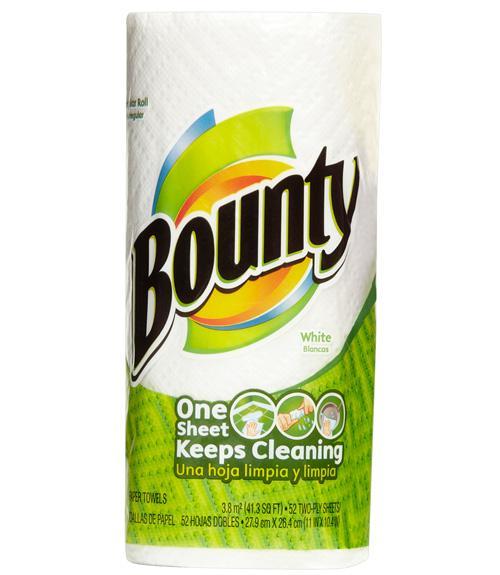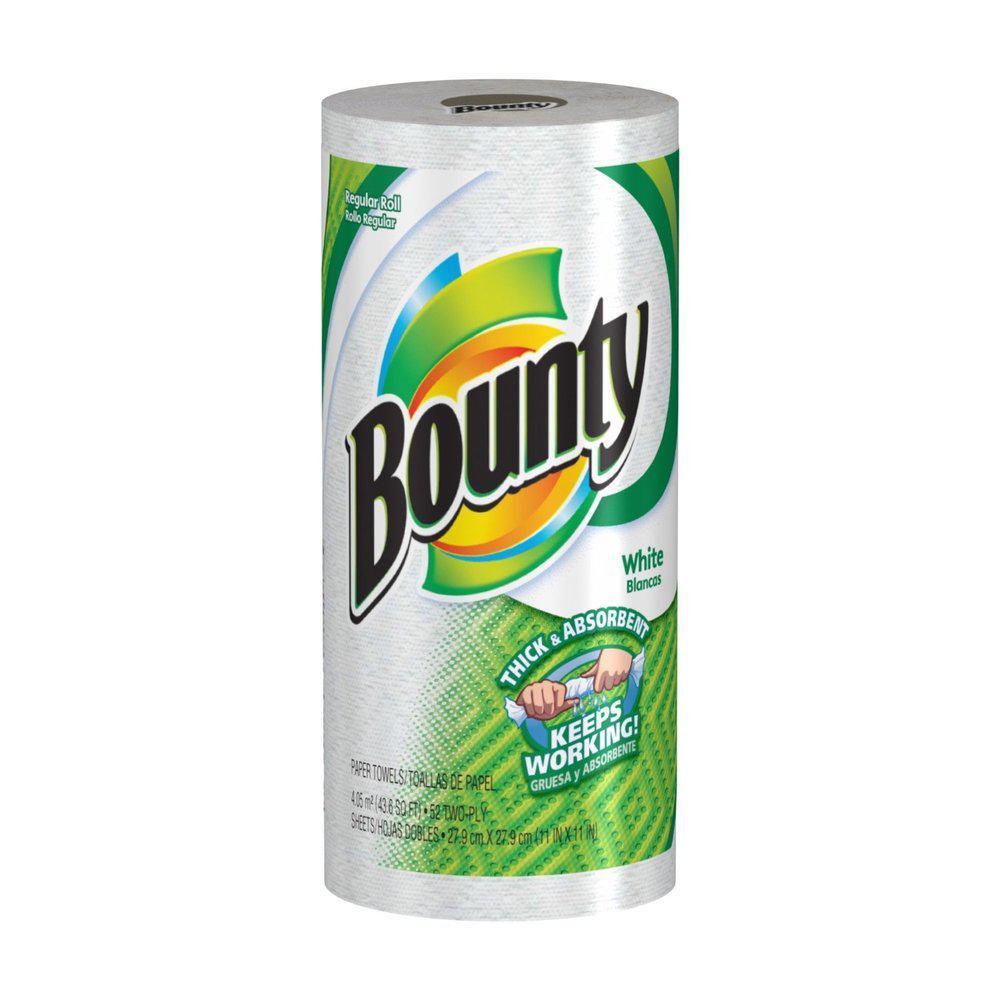The first image is the image on the left, the second image is the image on the right. Given the left and right images, does the statement "Each image shows a single upright roll of paper towels, and the left and right rolls do not have identical packaging." hold true? Answer yes or no. Yes. The first image is the image on the left, the second image is the image on the right. For the images displayed, is the sentence "There are exactly two rolls of paper towels." factually correct? Answer yes or no. Yes. 